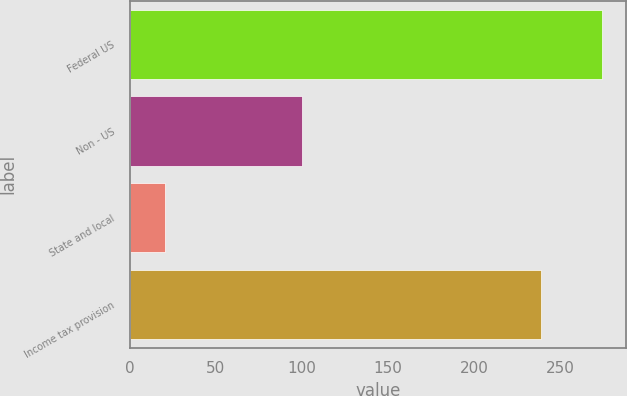Convert chart to OTSL. <chart><loc_0><loc_0><loc_500><loc_500><bar_chart><fcel>Federal US<fcel>Non - US<fcel>State and local<fcel>Income tax provision<nl><fcel>274.4<fcel>100.2<fcel>20.6<fcel>239<nl></chart> 